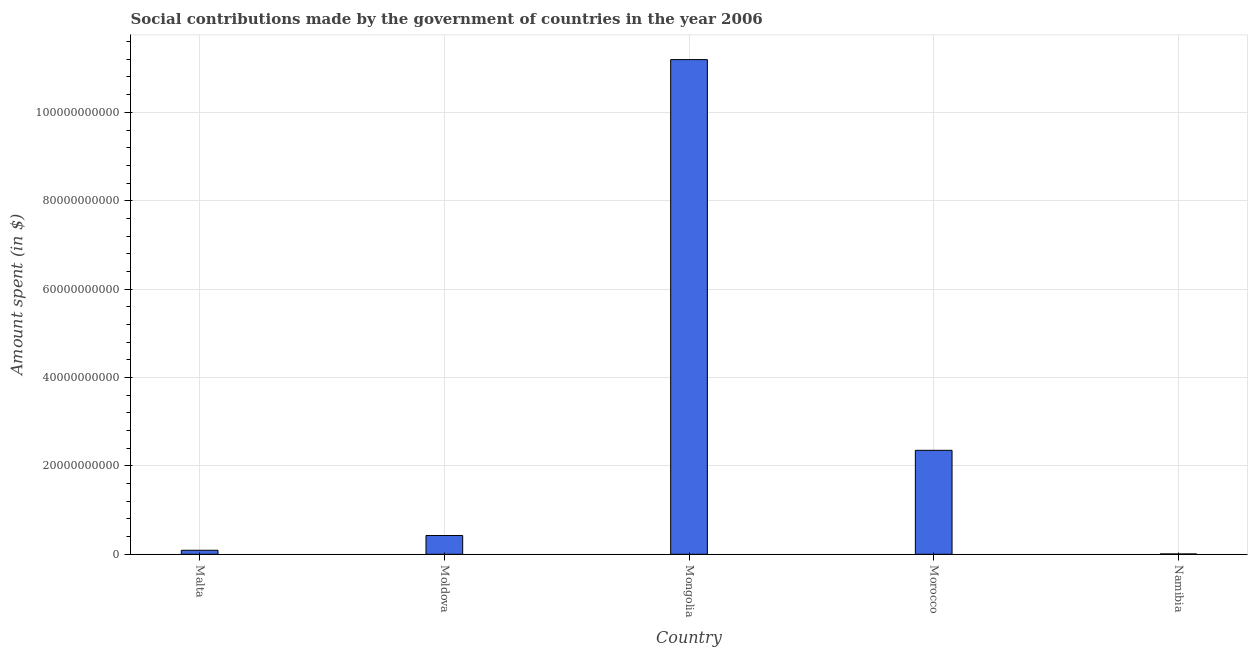Does the graph contain grids?
Your response must be concise. Yes. What is the title of the graph?
Make the answer very short. Social contributions made by the government of countries in the year 2006. What is the label or title of the Y-axis?
Your answer should be compact. Amount spent (in $). What is the amount spent in making social contributions in Namibia?
Ensure brevity in your answer.  7.47e+07. Across all countries, what is the maximum amount spent in making social contributions?
Provide a short and direct response. 1.12e+11. Across all countries, what is the minimum amount spent in making social contributions?
Make the answer very short. 7.47e+07. In which country was the amount spent in making social contributions maximum?
Provide a short and direct response. Mongolia. In which country was the amount spent in making social contributions minimum?
Keep it short and to the point. Namibia. What is the sum of the amount spent in making social contributions?
Your response must be concise. 1.41e+11. What is the difference between the amount spent in making social contributions in Malta and Namibia?
Make the answer very short. 8.33e+08. What is the average amount spent in making social contributions per country?
Provide a short and direct response. 2.81e+1. What is the median amount spent in making social contributions?
Your response must be concise. 4.24e+09. What is the ratio of the amount spent in making social contributions in Morocco to that in Namibia?
Provide a short and direct response. 315. Is the amount spent in making social contributions in Malta less than that in Mongolia?
Make the answer very short. Yes. What is the difference between the highest and the second highest amount spent in making social contributions?
Keep it short and to the point. 8.84e+1. What is the difference between the highest and the lowest amount spent in making social contributions?
Keep it short and to the point. 1.12e+11. In how many countries, is the amount spent in making social contributions greater than the average amount spent in making social contributions taken over all countries?
Provide a short and direct response. 1. How many bars are there?
Your response must be concise. 5. How many countries are there in the graph?
Offer a terse response. 5. What is the difference between two consecutive major ticks on the Y-axis?
Your response must be concise. 2.00e+1. What is the Amount spent (in $) in Malta?
Offer a terse response. 9.08e+08. What is the Amount spent (in $) in Moldova?
Your answer should be very brief. 4.24e+09. What is the Amount spent (in $) in Mongolia?
Make the answer very short. 1.12e+11. What is the Amount spent (in $) in Morocco?
Give a very brief answer. 2.35e+1. What is the Amount spent (in $) of Namibia?
Provide a short and direct response. 7.47e+07. What is the difference between the Amount spent (in $) in Malta and Moldova?
Make the answer very short. -3.34e+09. What is the difference between the Amount spent (in $) in Malta and Mongolia?
Give a very brief answer. -1.11e+11. What is the difference between the Amount spent (in $) in Malta and Morocco?
Your answer should be very brief. -2.26e+1. What is the difference between the Amount spent (in $) in Malta and Namibia?
Your response must be concise. 8.33e+08. What is the difference between the Amount spent (in $) in Moldova and Mongolia?
Make the answer very short. -1.08e+11. What is the difference between the Amount spent (in $) in Moldova and Morocco?
Offer a very short reply. -1.93e+1. What is the difference between the Amount spent (in $) in Moldova and Namibia?
Your answer should be very brief. 4.17e+09. What is the difference between the Amount spent (in $) in Mongolia and Morocco?
Ensure brevity in your answer.  8.84e+1. What is the difference between the Amount spent (in $) in Mongolia and Namibia?
Give a very brief answer. 1.12e+11. What is the difference between the Amount spent (in $) in Morocco and Namibia?
Your response must be concise. 2.34e+1. What is the ratio of the Amount spent (in $) in Malta to that in Moldova?
Offer a very short reply. 0.21. What is the ratio of the Amount spent (in $) in Malta to that in Mongolia?
Your answer should be compact. 0.01. What is the ratio of the Amount spent (in $) in Malta to that in Morocco?
Your answer should be compact. 0.04. What is the ratio of the Amount spent (in $) in Malta to that in Namibia?
Offer a very short reply. 12.16. What is the ratio of the Amount spent (in $) in Moldova to that in Mongolia?
Ensure brevity in your answer.  0.04. What is the ratio of the Amount spent (in $) in Moldova to that in Morocco?
Offer a very short reply. 0.18. What is the ratio of the Amount spent (in $) in Moldova to that in Namibia?
Your answer should be very brief. 56.83. What is the ratio of the Amount spent (in $) in Mongolia to that in Morocco?
Your answer should be very brief. 4.76. What is the ratio of the Amount spent (in $) in Mongolia to that in Namibia?
Keep it short and to the point. 1498.89. What is the ratio of the Amount spent (in $) in Morocco to that in Namibia?
Keep it short and to the point. 315. 